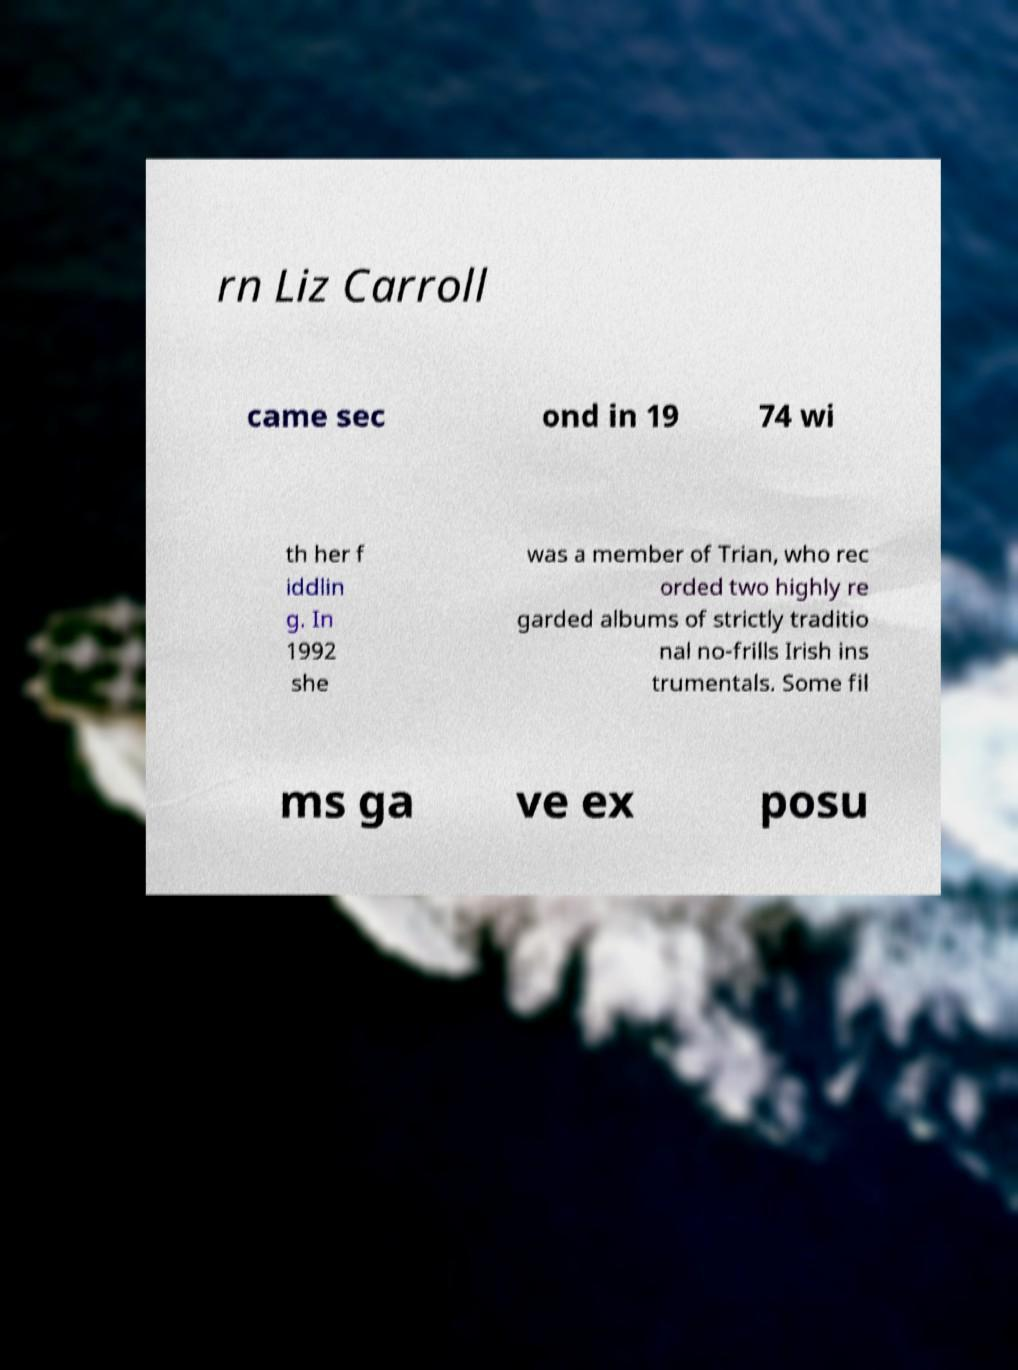What messages or text are displayed in this image? I need them in a readable, typed format. rn Liz Carroll came sec ond in 19 74 wi th her f iddlin g. In 1992 she was a member of Trian, who rec orded two highly re garded albums of strictly traditio nal no-frills Irish ins trumentals. Some fil ms ga ve ex posu 